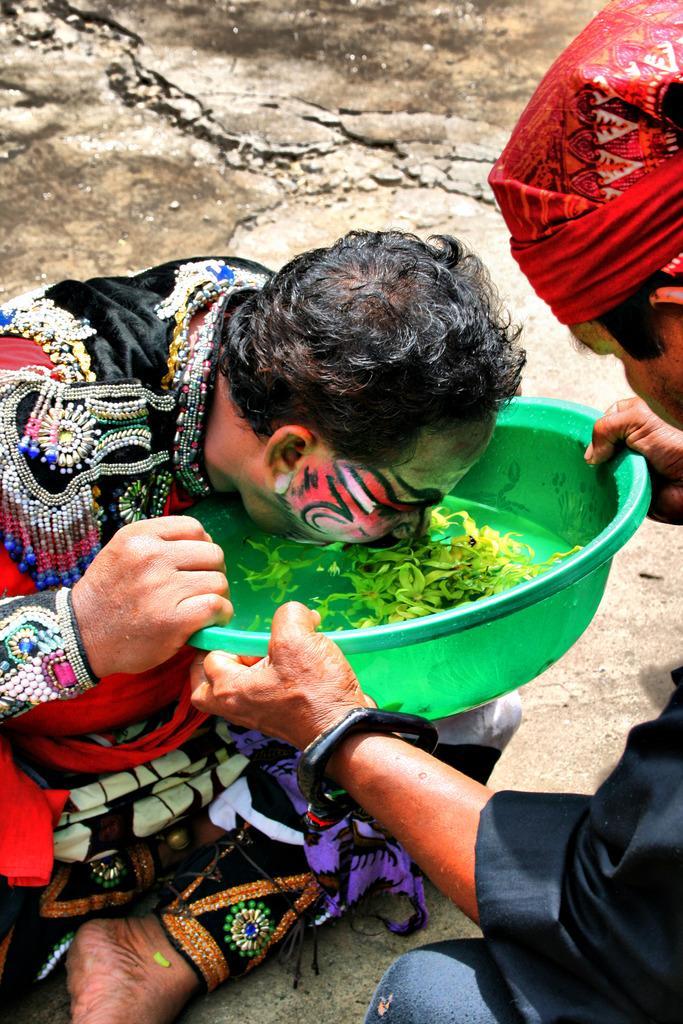Describe this image in one or two sentences. In this picture we can observe a person wearing black and red color dress sitting on the land. He is drinking some water in the green color bowl. On the right side there is another person. He is wearing red color cloth on his head. 